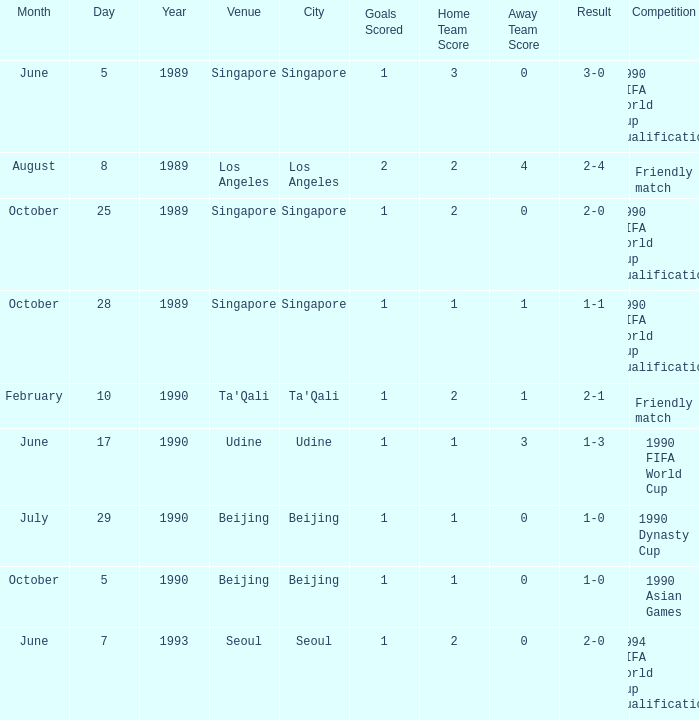Where were the 1990 asian games held? Beijing. 